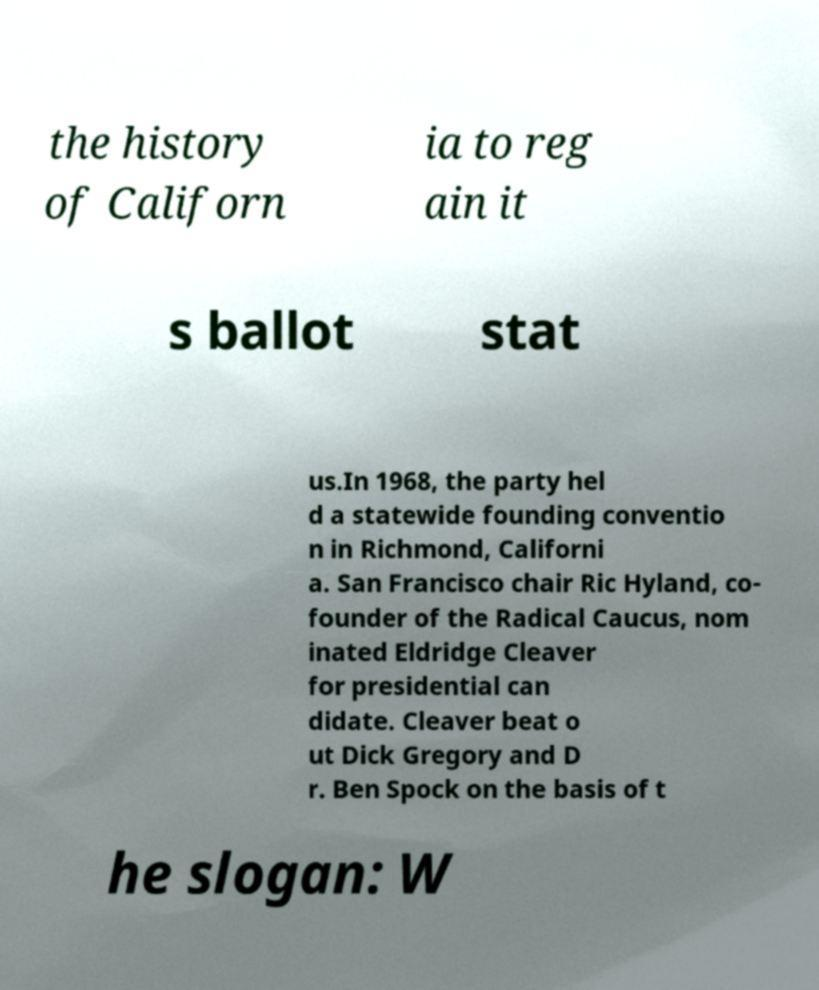Please read and relay the text visible in this image. What does it say? the history of Californ ia to reg ain it s ballot stat us.In 1968, the party hel d a statewide founding conventio n in Richmond, Californi a. San Francisco chair Ric Hyland, co- founder of the Radical Caucus, nom inated Eldridge Cleaver for presidential can didate. Cleaver beat o ut Dick Gregory and D r. Ben Spock on the basis of t he slogan: W 